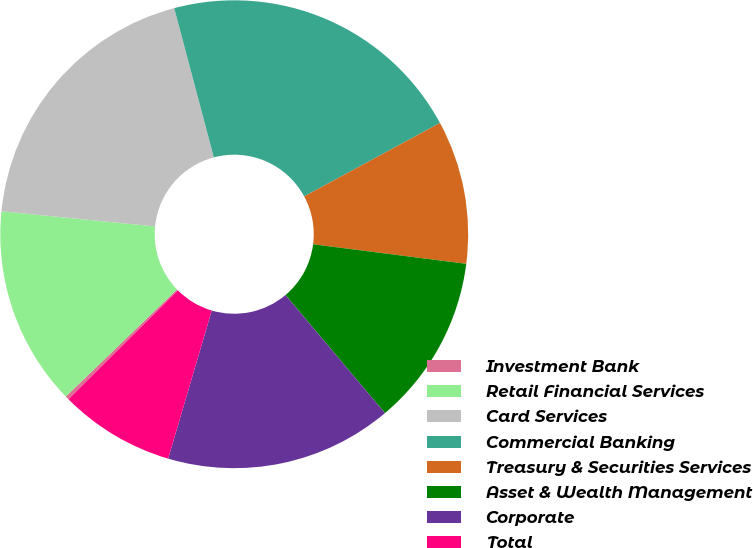<chart> <loc_0><loc_0><loc_500><loc_500><pie_chart><fcel>Investment Bank<fcel>Retail Financial Services<fcel>Card Services<fcel>Commercial Banking<fcel>Treasury & Securities Services<fcel>Asset & Wealth Management<fcel>Corporate<fcel>Total<nl><fcel>0.26%<fcel>13.77%<fcel>19.31%<fcel>21.24%<fcel>9.91%<fcel>11.84%<fcel>15.7%<fcel>7.98%<nl></chart> 